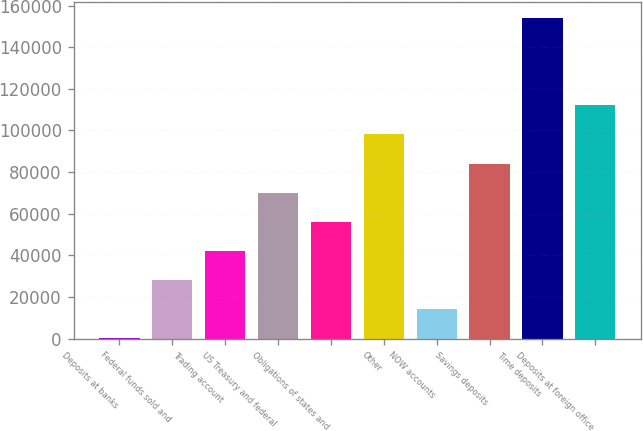Convert chart to OTSL. <chart><loc_0><loc_0><loc_500><loc_500><bar_chart><fcel>Deposits at banks<fcel>Federal funds sold and<fcel>Trading account<fcel>US Treasury and federal<fcel>Obligations of states and<fcel>Other<fcel>NOW accounts<fcel>Savings deposits<fcel>Time deposits<fcel>Deposits at foreign office<nl><fcel>104<fcel>28095.2<fcel>42090.8<fcel>70082<fcel>56086.4<fcel>98073.2<fcel>14099.6<fcel>84077.6<fcel>154056<fcel>112069<nl></chart> 